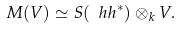Convert formula to latex. <formula><loc_0><loc_0><loc_500><loc_500>M ( V ) \simeq S ( \ h h ^ { * } ) \otimes _ { k } V .</formula> 